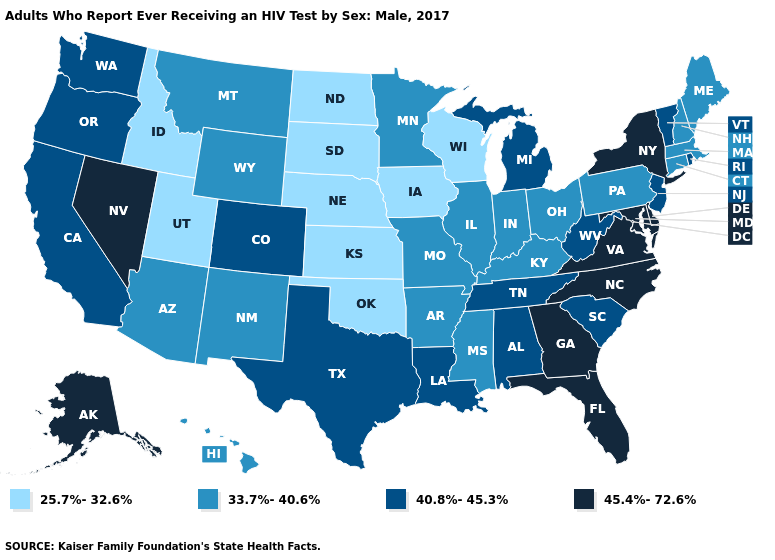Among the states that border Michigan , does Ohio have the lowest value?
Answer briefly. No. Name the states that have a value in the range 25.7%-32.6%?
Write a very short answer. Idaho, Iowa, Kansas, Nebraska, North Dakota, Oklahoma, South Dakota, Utah, Wisconsin. What is the highest value in the USA?
Write a very short answer. 45.4%-72.6%. What is the value of New Hampshire?
Write a very short answer. 33.7%-40.6%. What is the value of South Carolina?
Keep it brief. 40.8%-45.3%. Does Vermont have the lowest value in the Northeast?
Quick response, please. No. What is the value of Wyoming?
Write a very short answer. 33.7%-40.6%. Does Nevada have the highest value in the USA?
Give a very brief answer. Yes. What is the highest value in the USA?
Short answer required. 45.4%-72.6%. How many symbols are there in the legend?
Concise answer only. 4. What is the lowest value in states that border Illinois?
Concise answer only. 25.7%-32.6%. What is the lowest value in the MidWest?
Keep it brief. 25.7%-32.6%. Which states hav the highest value in the Northeast?
Write a very short answer. New York. What is the lowest value in the USA?
Write a very short answer. 25.7%-32.6%. Does Louisiana have the highest value in the USA?
Keep it brief. No. 